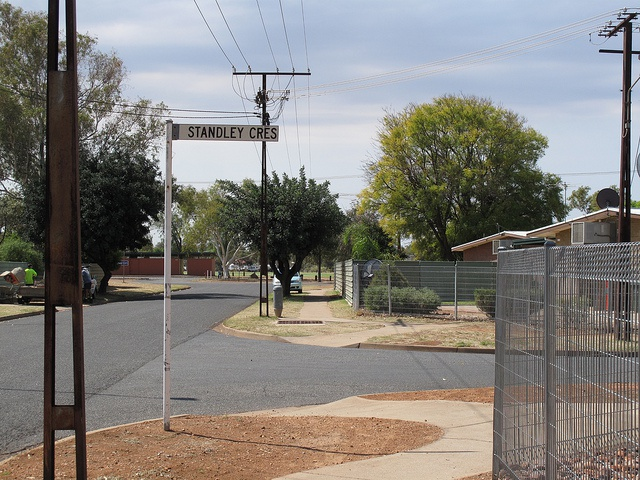Describe the objects in this image and their specific colors. I can see car in darkgray, gray, black, and lightgray tones, people in darkgray, black, and gray tones, and people in darkgray, darkgreen, green, and black tones in this image. 